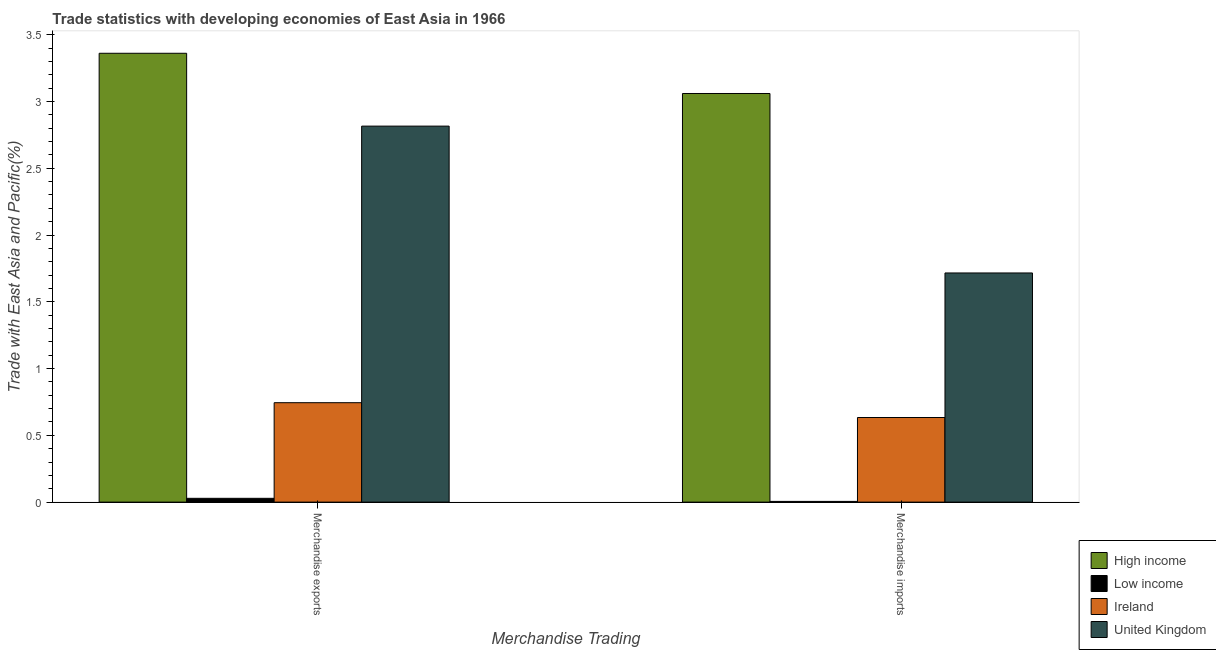Are the number of bars on each tick of the X-axis equal?
Ensure brevity in your answer.  Yes. How many bars are there on the 2nd tick from the left?
Provide a short and direct response. 4. What is the label of the 2nd group of bars from the left?
Ensure brevity in your answer.  Merchandise imports. What is the merchandise exports in Ireland?
Provide a short and direct response. 0.74. Across all countries, what is the maximum merchandise imports?
Make the answer very short. 3.06. Across all countries, what is the minimum merchandise imports?
Your answer should be compact. 0.01. In which country was the merchandise imports maximum?
Give a very brief answer. High income. In which country was the merchandise exports minimum?
Ensure brevity in your answer.  Low income. What is the total merchandise exports in the graph?
Your answer should be very brief. 6.95. What is the difference between the merchandise imports in Ireland and that in Low income?
Make the answer very short. 0.63. What is the difference between the merchandise exports in Low income and the merchandise imports in United Kingdom?
Ensure brevity in your answer.  -1.69. What is the average merchandise imports per country?
Offer a very short reply. 1.35. What is the difference between the merchandise exports and merchandise imports in United Kingdom?
Give a very brief answer. 1.1. What is the ratio of the merchandise exports in United Kingdom to that in High income?
Ensure brevity in your answer.  0.84. What does the 3rd bar from the left in Merchandise exports represents?
Your answer should be compact. Ireland. What does the 1st bar from the right in Merchandise exports represents?
Your answer should be compact. United Kingdom. How many bars are there?
Your answer should be compact. 8. Are all the bars in the graph horizontal?
Your answer should be very brief. No. How many countries are there in the graph?
Your answer should be compact. 4. What is the difference between two consecutive major ticks on the Y-axis?
Give a very brief answer. 0.5. Are the values on the major ticks of Y-axis written in scientific E-notation?
Offer a very short reply. No. Does the graph contain any zero values?
Give a very brief answer. No. How many legend labels are there?
Ensure brevity in your answer.  4. What is the title of the graph?
Provide a short and direct response. Trade statistics with developing economies of East Asia in 1966. Does "Tajikistan" appear as one of the legend labels in the graph?
Ensure brevity in your answer.  No. What is the label or title of the X-axis?
Make the answer very short. Merchandise Trading. What is the label or title of the Y-axis?
Your answer should be compact. Trade with East Asia and Pacific(%). What is the Trade with East Asia and Pacific(%) of High income in Merchandise exports?
Your answer should be compact. 3.36. What is the Trade with East Asia and Pacific(%) in Low income in Merchandise exports?
Ensure brevity in your answer.  0.03. What is the Trade with East Asia and Pacific(%) of Ireland in Merchandise exports?
Make the answer very short. 0.74. What is the Trade with East Asia and Pacific(%) in United Kingdom in Merchandise exports?
Provide a short and direct response. 2.82. What is the Trade with East Asia and Pacific(%) in High income in Merchandise imports?
Offer a terse response. 3.06. What is the Trade with East Asia and Pacific(%) of Low income in Merchandise imports?
Your answer should be very brief. 0.01. What is the Trade with East Asia and Pacific(%) in Ireland in Merchandise imports?
Offer a very short reply. 0.63. What is the Trade with East Asia and Pacific(%) of United Kingdom in Merchandise imports?
Keep it short and to the point. 1.72. Across all Merchandise Trading, what is the maximum Trade with East Asia and Pacific(%) in High income?
Give a very brief answer. 3.36. Across all Merchandise Trading, what is the maximum Trade with East Asia and Pacific(%) in Low income?
Offer a very short reply. 0.03. Across all Merchandise Trading, what is the maximum Trade with East Asia and Pacific(%) of Ireland?
Provide a short and direct response. 0.74. Across all Merchandise Trading, what is the maximum Trade with East Asia and Pacific(%) of United Kingdom?
Provide a succinct answer. 2.82. Across all Merchandise Trading, what is the minimum Trade with East Asia and Pacific(%) in High income?
Keep it short and to the point. 3.06. Across all Merchandise Trading, what is the minimum Trade with East Asia and Pacific(%) in Low income?
Provide a short and direct response. 0.01. Across all Merchandise Trading, what is the minimum Trade with East Asia and Pacific(%) in Ireland?
Your response must be concise. 0.63. Across all Merchandise Trading, what is the minimum Trade with East Asia and Pacific(%) in United Kingdom?
Offer a terse response. 1.72. What is the total Trade with East Asia and Pacific(%) in High income in the graph?
Your answer should be compact. 6.42. What is the total Trade with East Asia and Pacific(%) of Low income in the graph?
Offer a very short reply. 0.03. What is the total Trade with East Asia and Pacific(%) of Ireland in the graph?
Your answer should be very brief. 1.38. What is the total Trade with East Asia and Pacific(%) of United Kingdom in the graph?
Ensure brevity in your answer.  4.53. What is the difference between the Trade with East Asia and Pacific(%) in High income in Merchandise exports and that in Merchandise imports?
Make the answer very short. 0.3. What is the difference between the Trade with East Asia and Pacific(%) of Low income in Merchandise exports and that in Merchandise imports?
Give a very brief answer. 0.02. What is the difference between the Trade with East Asia and Pacific(%) of Ireland in Merchandise exports and that in Merchandise imports?
Offer a very short reply. 0.11. What is the difference between the Trade with East Asia and Pacific(%) in United Kingdom in Merchandise exports and that in Merchandise imports?
Offer a very short reply. 1.1. What is the difference between the Trade with East Asia and Pacific(%) in High income in Merchandise exports and the Trade with East Asia and Pacific(%) in Low income in Merchandise imports?
Make the answer very short. 3.36. What is the difference between the Trade with East Asia and Pacific(%) of High income in Merchandise exports and the Trade with East Asia and Pacific(%) of Ireland in Merchandise imports?
Keep it short and to the point. 2.73. What is the difference between the Trade with East Asia and Pacific(%) of High income in Merchandise exports and the Trade with East Asia and Pacific(%) of United Kingdom in Merchandise imports?
Provide a short and direct response. 1.65. What is the difference between the Trade with East Asia and Pacific(%) of Low income in Merchandise exports and the Trade with East Asia and Pacific(%) of Ireland in Merchandise imports?
Offer a terse response. -0.61. What is the difference between the Trade with East Asia and Pacific(%) of Low income in Merchandise exports and the Trade with East Asia and Pacific(%) of United Kingdom in Merchandise imports?
Provide a succinct answer. -1.69. What is the difference between the Trade with East Asia and Pacific(%) in Ireland in Merchandise exports and the Trade with East Asia and Pacific(%) in United Kingdom in Merchandise imports?
Your answer should be very brief. -0.97. What is the average Trade with East Asia and Pacific(%) of High income per Merchandise Trading?
Your answer should be compact. 3.21. What is the average Trade with East Asia and Pacific(%) in Low income per Merchandise Trading?
Your answer should be very brief. 0.02. What is the average Trade with East Asia and Pacific(%) of Ireland per Merchandise Trading?
Your answer should be very brief. 0.69. What is the average Trade with East Asia and Pacific(%) in United Kingdom per Merchandise Trading?
Ensure brevity in your answer.  2.27. What is the difference between the Trade with East Asia and Pacific(%) of High income and Trade with East Asia and Pacific(%) of Low income in Merchandise exports?
Your answer should be compact. 3.33. What is the difference between the Trade with East Asia and Pacific(%) in High income and Trade with East Asia and Pacific(%) in Ireland in Merchandise exports?
Your answer should be very brief. 2.62. What is the difference between the Trade with East Asia and Pacific(%) in High income and Trade with East Asia and Pacific(%) in United Kingdom in Merchandise exports?
Provide a short and direct response. 0.55. What is the difference between the Trade with East Asia and Pacific(%) of Low income and Trade with East Asia and Pacific(%) of Ireland in Merchandise exports?
Your response must be concise. -0.72. What is the difference between the Trade with East Asia and Pacific(%) in Low income and Trade with East Asia and Pacific(%) in United Kingdom in Merchandise exports?
Your answer should be very brief. -2.79. What is the difference between the Trade with East Asia and Pacific(%) of Ireland and Trade with East Asia and Pacific(%) of United Kingdom in Merchandise exports?
Make the answer very short. -2.07. What is the difference between the Trade with East Asia and Pacific(%) in High income and Trade with East Asia and Pacific(%) in Low income in Merchandise imports?
Ensure brevity in your answer.  3.05. What is the difference between the Trade with East Asia and Pacific(%) in High income and Trade with East Asia and Pacific(%) in Ireland in Merchandise imports?
Your answer should be very brief. 2.43. What is the difference between the Trade with East Asia and Pacific(%) of High income and Trade with East Asia and Pacific(%) of United Kingdom in Merchandise imports?
Your response must be concise. 1.34. What is the difference between the Trade with East Asia and Pacific(%) in Low income and Trade with East Asia and Pacific(%) in Ireland in Merchandise imports?
Ensure brevity in your answer.  -0.63. What is the difference between the Trade with East Asia and Pacific(%) in Low income and Trade with East Asia and Pacific(%) in United Kingdom in Merchandise imports?
Give a very brief answer. -1.71. What is the difference between the Trade with East Asia and Pacific(%) of Ireland and Trade with East Asia and Pacific(%) of United Kingdom in Merchandise imports?
Make the answer very short. -1.08. What is the ratio of the Trade with East Asia and Pacific(%) of High income in Merchandise exports to that in Merchandise imports?
Provide a succinct answer. 1.1. What is the ratio of the Trade with East Asia and Pacific(%) of Low income in Merchandise exports to that in Merchandise imports?
Give a very brief answer. 5.25. What is the ratio of the Trade with East Asia and Pacific(%) in Ireland in Merchandise exports to that in Merchandise imports?
Give a very brief answer. 1.18. What is the ratio of the Trade with East Asia and Pacific(%) in United Kingdom in Merchandise exports to that in Merchandise imports?
Provide a succinct answer. 1.64. What is the difference between the highest and the second highest Trade with East Asia and Pacific(%) in High income?
Your answer should be very brief. 0.3. What is the difference between the highest and the second highest Trade with East Asia and Pacific(%) in Low income?
Ensure brevity in your answer.  0.02. What is the difference between the highest and the second highest Trade with East Asia and Pacific(%) of Ireland?
Offer a terse response. 0.11. What is the difference between the highest and the second highest Trade with East Asia and Pacific(%) in United Kingdom?
Your answer should be very brief. 1.1. What is the difference between the highest and the lowest Trade with East Asia and Pacific(%) in High income?
Provide a succinct answer. 0.3. What is the difference between the highest and the lowest Trade with East Asia and Pacific(%) in Low income?
Your answer should be very brief. 0.02. What is the difference between the highest and the lowest Trade with East Asia and Pacific(%) in Ireland?
Your answer should be very brief. 0.11. What is the difference between the highest and the lowest Trade with East Asia and Pacific(%) in United Kingdom?
Make the answer very short. 1.1. 